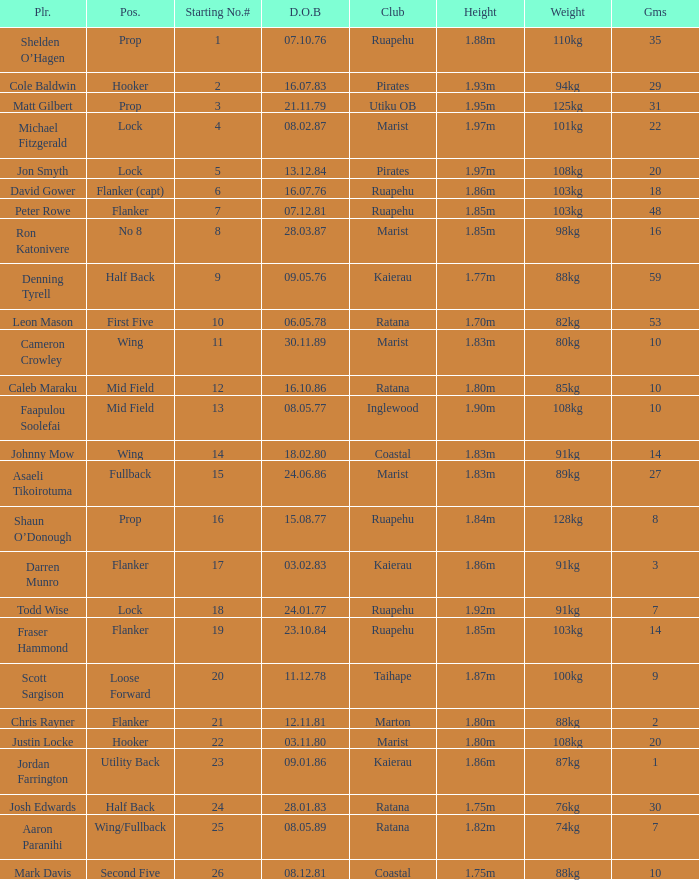Can you give me this table as a dict? {'header': ['Plr.', 'Pos.', 'Starting No.#', 'D.O.B', 'Club', 'Height', 'Weight', 'Gms'], 'rows': [['Shelden O’Hagen', 'Prop', '1', '07.10.76', 'Ruapehu', '1.88m', '110kg', '35'], ['Cole Baldwin', 'Hooker', '2', '16.07.83', 'Pirates', '1.93m', '94kg', '29'], ['Matt Gilbert', 'Prop', '3', '21.11.79', 'Utiku OB', '1.95m', '125kg', '31'], ['Michael Fitzgerald', 'Lock', '4', '08.02.87', 'Marist', '1.97m', '101kg', '22'], ['Jon Smyth', 'Lock', '5', '13.12.84', 'Pirates', '1.97m', '108kg', '20'], ['David Gower', 'Flanker (capt)', '6', '16.07.76', 'Ruapehu', '1.86m', '103kg', '18'], ['Peter Rowe', 'Flanker', '7', '07.12.81', 'Ruapehu', '1.85m', '103kg', '48'], ['Ron Katonivere', 'No 8', '8', '28.03.87', 'Marist', '1.85m', '98kg', '16'], ['Denning Tyrell', 'Half Back', '9', '09.05.76', 'Kaierau', '1.77m', '88kg', '59'], ['Leon Mason', 'First Five', '10', '06.05.78', 'Ratana', '1.70m', '82kg', '53'], ['Cameron Crowley', 'Wing', '11', '30.11.89', 'Marist', '1.83m', '80kg', '10'], ['Caleb Maraku', 'Mid Field', '12', '16.10.86', 'Ratana', '1.80m', '85kg', '10'], ['Faapulou Soolefai', 'Mid Field', '13', '08.05.77', 'Inglewood', '1.90m', '108kg', '10'], ['Johnny Mow', 'Wing', '14', '18.02.80', 'Coastal', '1.83m', '91kg', '14'], ['Asaeli Tikoirotuma', 'Fullback', '15', '24.06.86', 'Marist', '1.83m', '89kg', '27'], ['Shaun O’Donough', 'Prop', '16', '15.08.77', 'Ruapehu', '1.84m', '128kg', '8'], ['Darren Munro', 'Flanker', '17', '03.02.83', 'Kaierau', '1.86m', '91kg', '3'], ['Todd Wise', 'Lock', '18', '24.01.77', 'Ruapehu', '1.92m', '91kg', '7'], ['Fraser Hammond', 'Flanker', '19', '23.10.84', 'Ruapehu', '1.85m', '103kg', '14'], ['Scott Sargison', 'Loose Forward', '20', '11.12.78', 'Taihape', '1.87m', '100kg', '9'], ['Chris Rayner', 'Flanker', '21', '12.11.81', 'Marton', '1.80m', '88kg', '2'], ['Justin Locke', 'Hooker', '22', '03.11.80', 'Marist', '1.80m', '108kg', '20'], ['Jordan Farrington', 'Utility Back', '23', '09.01.86', 'Kaierau', '1.86m', '87kg', '1'], ['Josh Edwards', 'Half Back', '24', '28.01.83', 'Ratana', '1.75m', '76kg', '30'], ['Aaron Paranihi', 'Wing/Fullback', '25', '08.05.89', 'Ratana', '1.82m', '74kg', '7'], ['Mark Davis', 'Second Five', '26', '08.12.81', 'Coastal', '1.75m', '88kg', '10']]} How many games were played where the height of the player is 1.92m? 1.0. 